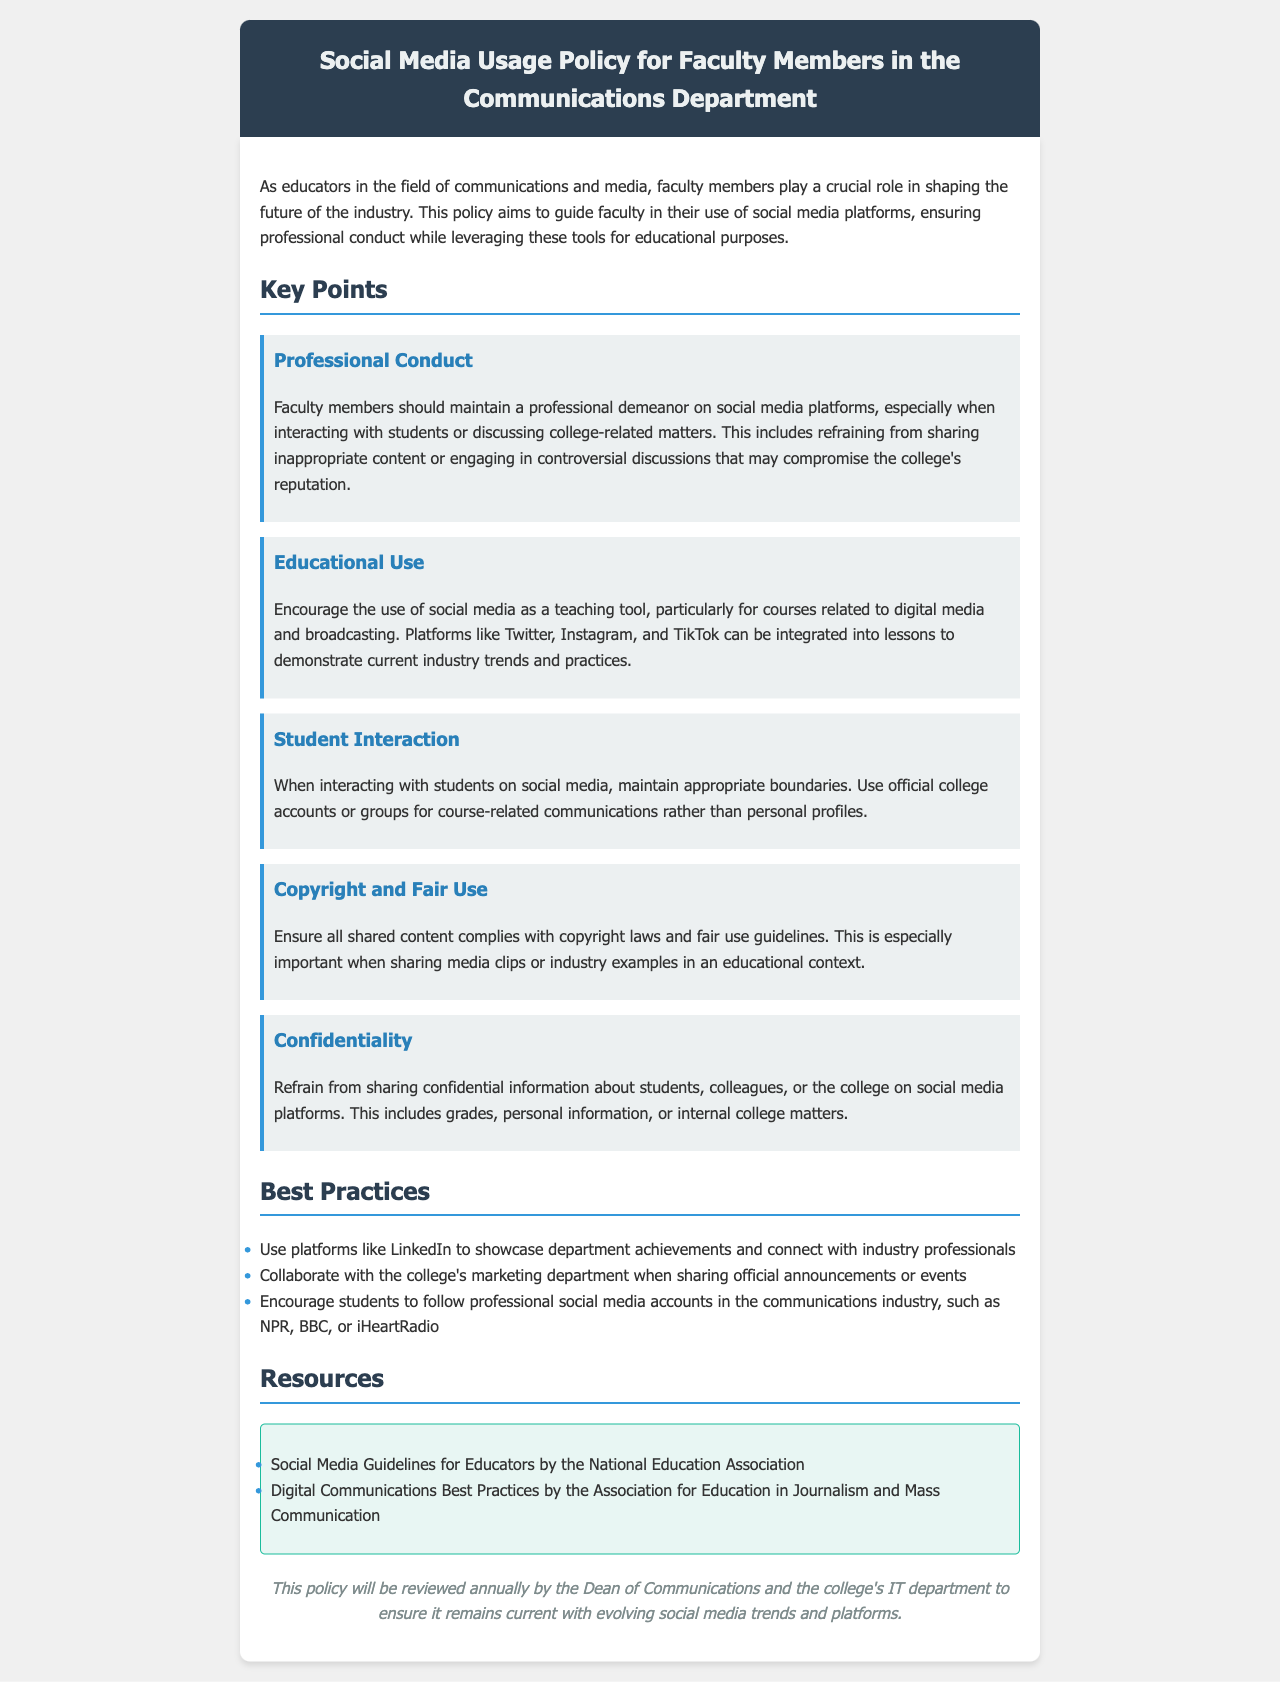what is the title of the document? The title of the document provides a clear indication of its subject and intended audience.
Answer: Social Media Usage Policy for Faculty Members in the Communications Department what is the first key point outlined in the policy? The first key point introduces the primary expectation for faculty members regarding their social media behavior.
Answer: Professional Conduct how often will the policy be reviewed? The review period for the policy indicates how frequently updates will be considered to keep it relevant.
Answer: Annually which social media platforms are mentioned as teaching tools? The specific platforms listed provide insight into how faculty members can utilize social media for educational purposes.
Answer: Twitter, Instagram, TikTok what type of content must be shared in compliance with laws? This part of the document emphasizes the legal considerations faculty need to keep in mind when sharing content.
Answer: Copyright laws and fair use which department should faculty collaborate with for official announcements? The collaboration highlights the importance of proper communication channels within the institution.
Answer: College's marketing department what is the purpose of this policy? Understanding the main objective of the document helps to clarify its significance to faculty members.
Answer: Guide faculty in their use of social media platforms what does the policy state about student interaction? This portion specifies the expected boundaries between faculty and students in a digital environment.
Answer: Maintain appropriate boundaries what is one recommended best practice for faculty using social media? This question identifies practical advice given within the policy to enhance faculty social media presence.
Answer: Use platforms like LinkedIn 